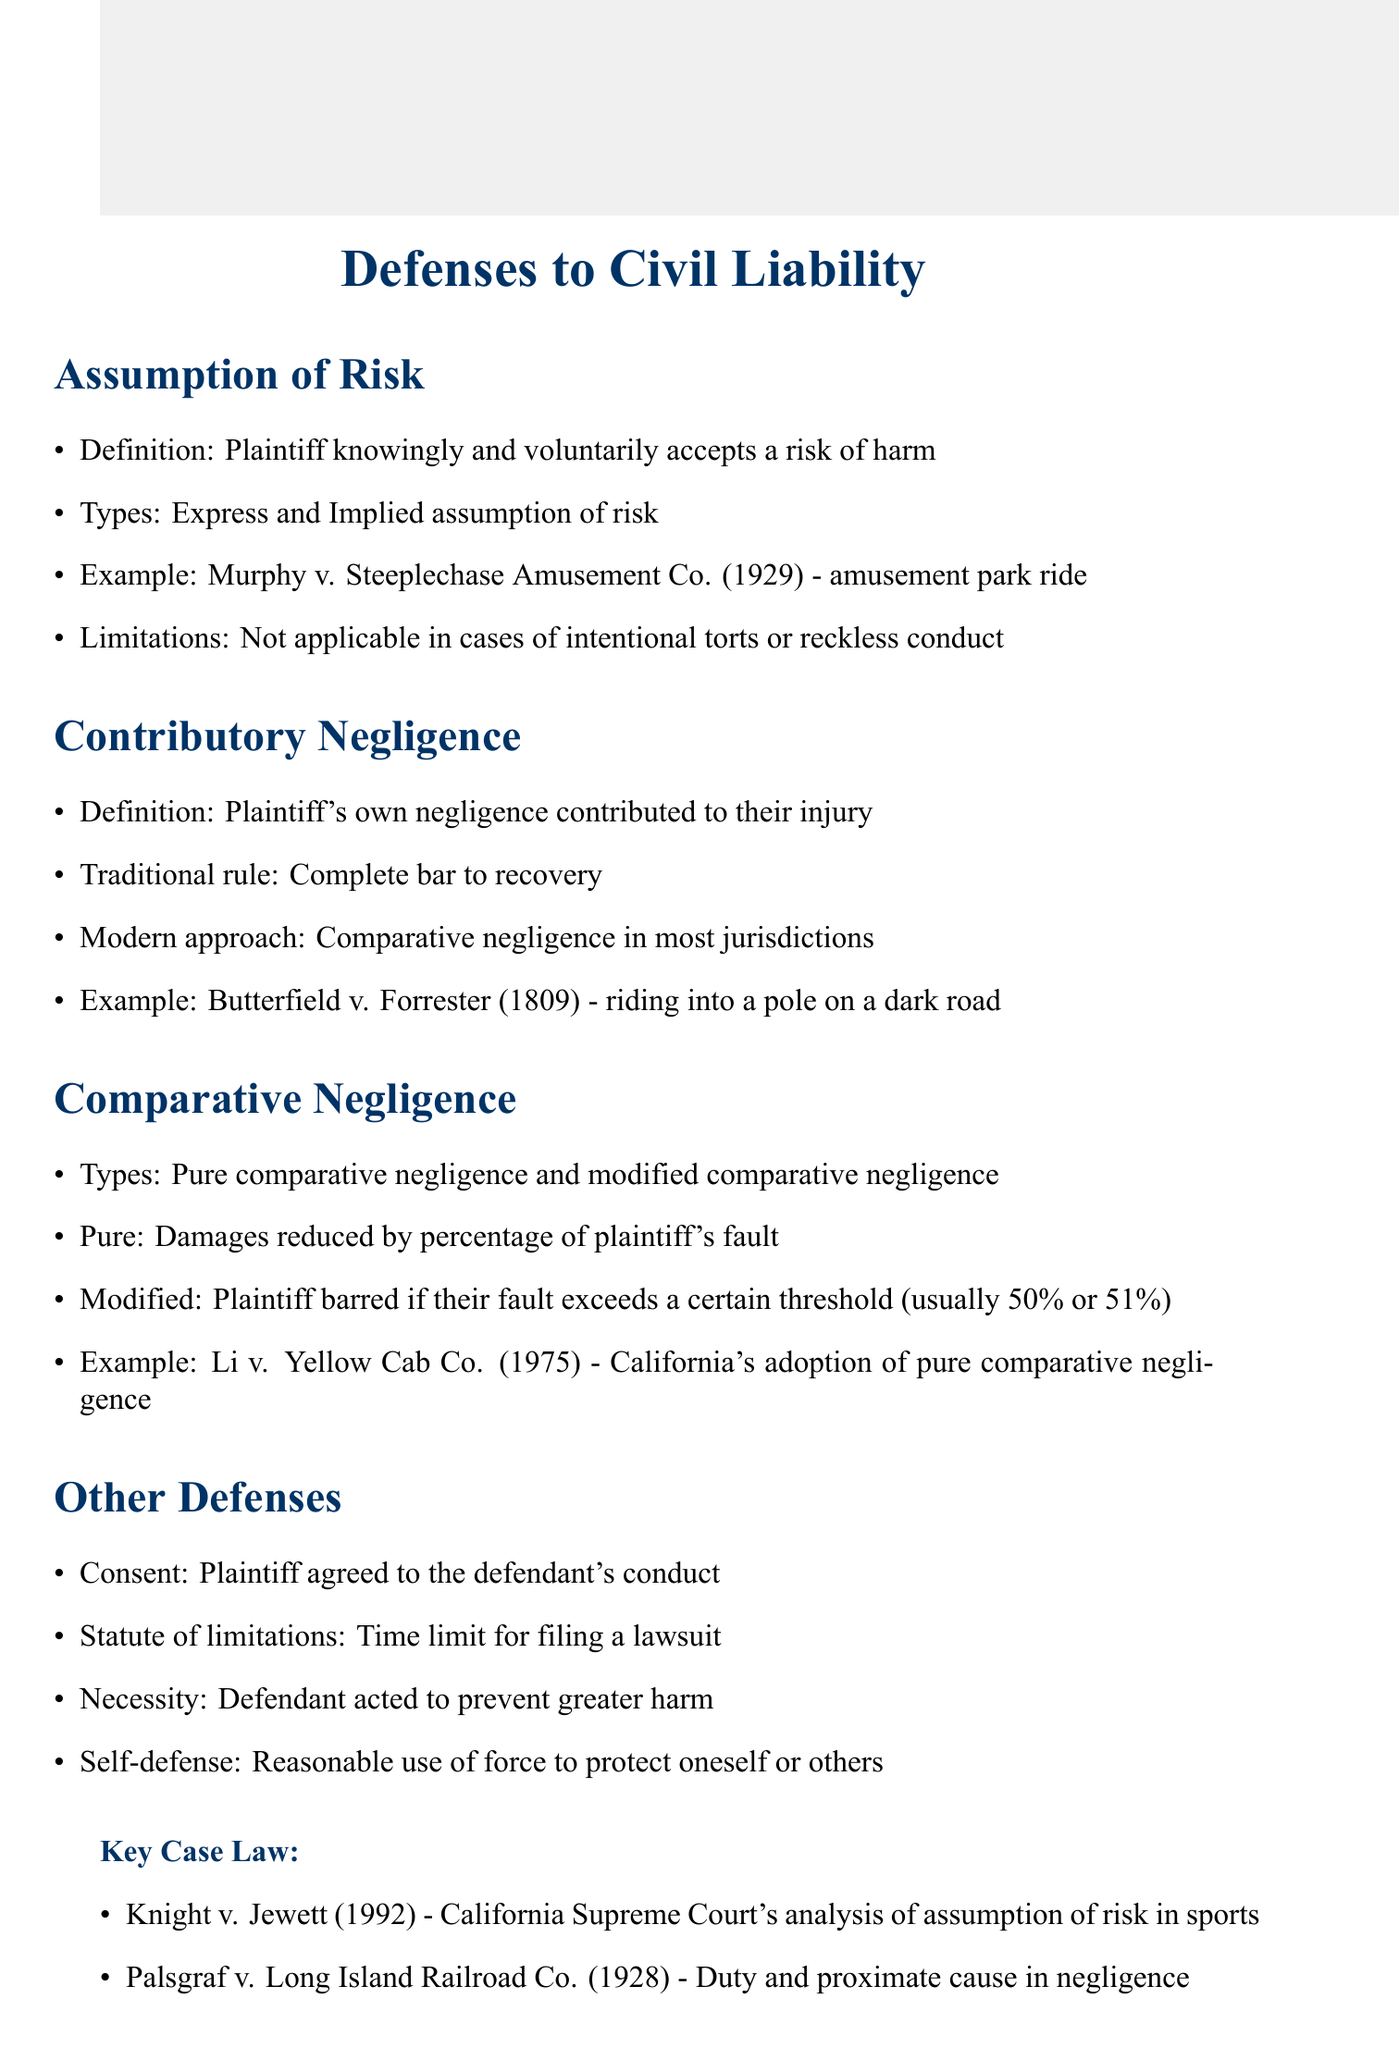What is the definition of Assumption of Risk? The definition states that the plaintiff knowingly and voluntarily accepts a risk of harm.
Answer: Plaintiff knowingly and voluntarily accepts a risk of harm What type of negligence allows for a complete bar to recovery? The traditional rule of contributory negligence establishes that the plaintiff's own negligence contributes to their injury and serves as a complete bar to recovery.
Answer: Contributory negligence Which case exemplifies the principle of Assumption of Risk in sports? Knight v. Jewett (1992) is specifically mentioned as an analysis of assumption of risk in sports.
Answer: Knight v. Jewett (1992) What is the threshold for modified comparative negligence in most jurisdictions? The document indicates that the threshold is usually 50% or 51% for modified comparative negligence.
Answer: 50% or 51% What is one limitation of Assumption of Risk? The limitation states that it is not applicable in cases of intentional torts or reckless conduct.
Answer: Not applicable in cases of intentional torts or reckless conduct How does pure comparative negligence affect damages? The document describes that damages are reduced by the percentage of the plaintiff's fault under pure comparative negligence.
Answer: Reduced by percentage of plaintiff's fault What are two types of assumption of risk? The key points indicate that assumption of risk can be express or implied.
Answer: Express and implied What does the study group highlight as a trend in U.S. jurisdictions? It mentions the trend towards comparative fault systems in most U.S. jurisdictions.
Answer: Comparative fault systems 